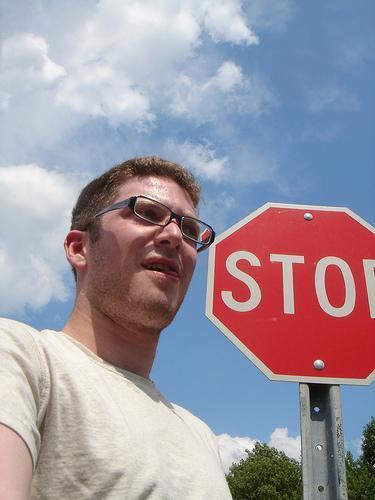How many people are in the picture?
Give a very brief answer. 1. 